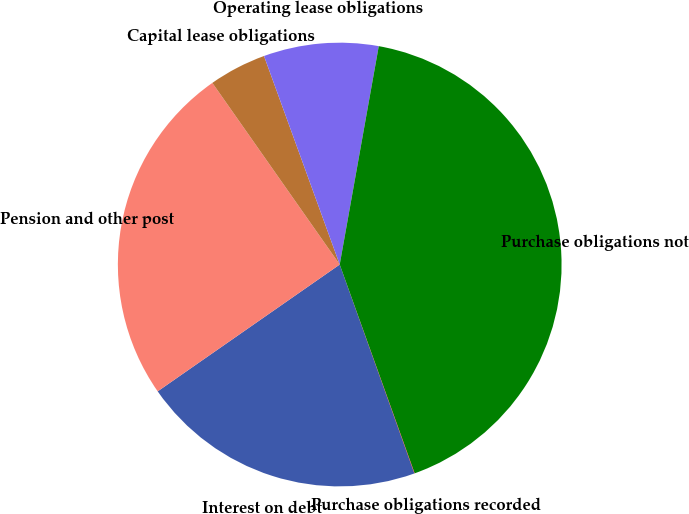<chart> <loc_0><loc_0><loc_500><loc_500><pie_chart><fcel>Interest on debt<fcel>Pension and other post<fcel>Capital lease obligations<fcel>Operating lease obligations<fcel>Purchase obligations not<fcel>Purchase obligations recorded<nl><fcel>20.78%<fcel>24.95%<fcel>4.19%<fcel>8.36%<fcel>41.7%<fcel>0.02%<nl></chart> 